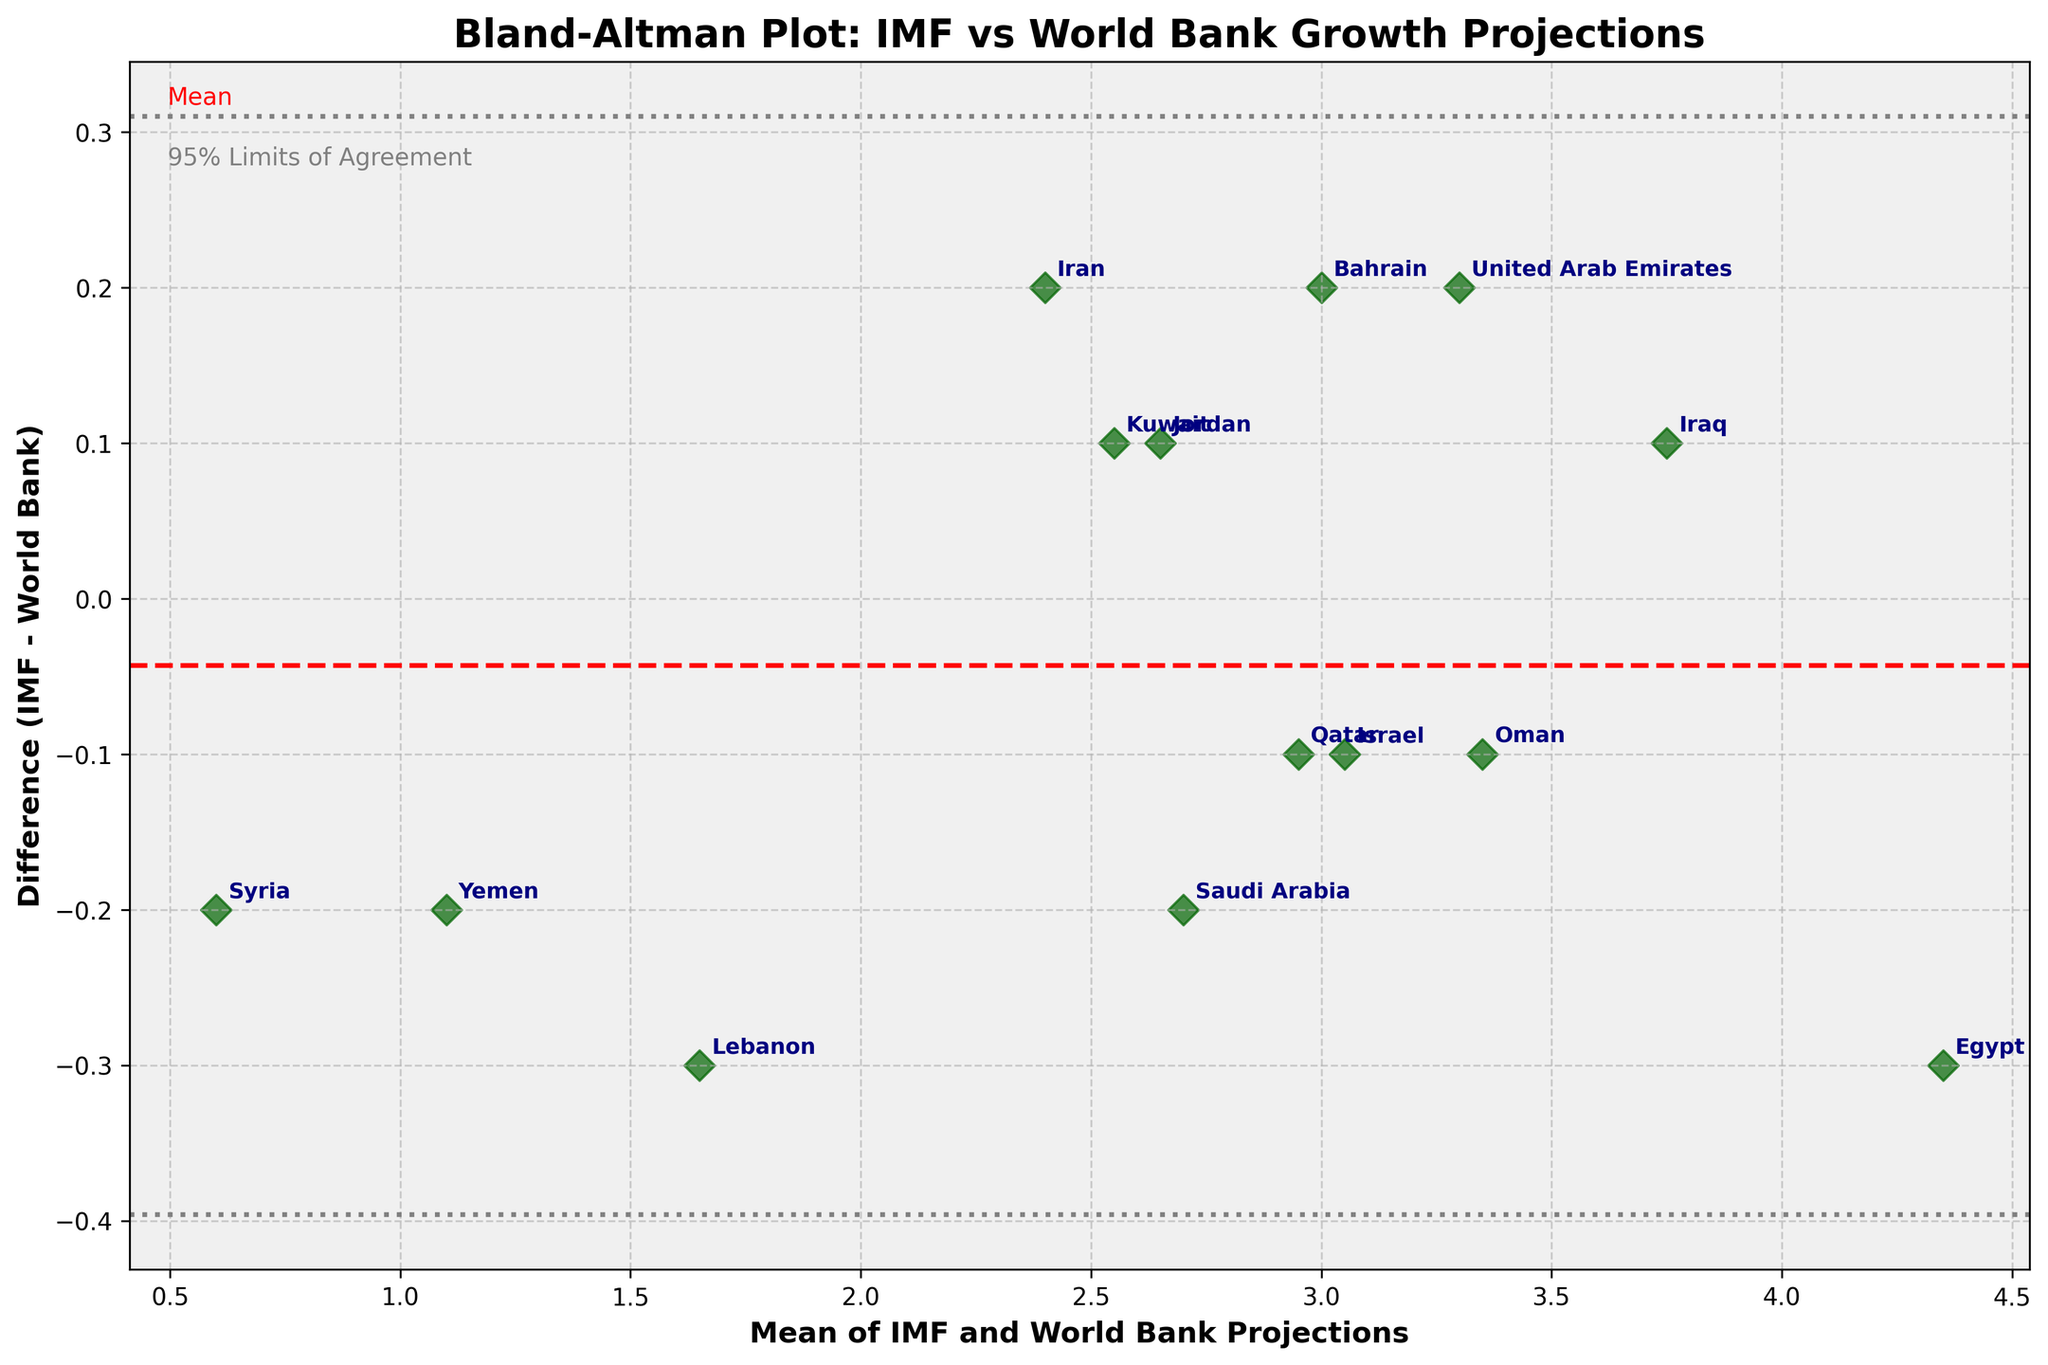How many countries are represented in the plot? By counting the countries listed in the dataset or their points on the plot, you will get the total number of represented countries. There are 14 countries listed.
Answer: 14 What's the title of the plot? The plot's title is positioned at the top of the figure and describes the main subject of the visualization. It reads, "Bland-Altman Plot: IMF vs World Bank Growth Projections".
Answer: Bland-Altman Plot: IMF vs World Bank Growth Projections What is the range of the mean of IMF and World Bank projections displayed on the x-axis? Observing the x-axis, the minimum and maximum values can be identified from the data points. The range is approximately from 0.6 to 4.35.
Answer: 0.6 to 4.35 Which country has the largest difference between IMF and World Bank projections? By examining the vertical distance of each point from the zero line on the y-axis, "Egypt" has the largest difference with a positive value of 0.3.
Answer: Egypt What does the red dashed horizontal line represent? The red dashed line typically represents the mean difference between the IMF and World Bank projections for all countries. This line helps identify any systematic bias.
Answer: Mean difference How many countries have higher IMF projections compared to World Bank projections? To find this, count the data points that are above the zero line on the y-axis, which represents positive differences (IMF is higher). There are 8 such points.
Answer: 8 Which country has the smallest absolute difference between the two projections and where is it located on the plot? By examining the closeness of points to the zero line on the y-axis, "Israel" has the smallest absolute difference, shown very close to zero.
Answer: Israel What do the gray dotted lines represent in the plot? These lines indicate the "95% Limits of Agreement," meaning most of the differences between IMF and World Bank projections should fall within these lines.
Answer: 95% Limits of Agreement What's the average IMF projection for the countries plotted? Adding all the IMF projections and dividing by the number of countries gives the average. (2.6 + 3.4 + 4.2 + 2.5 + 3.8 + 3.0 + 2.7 + 2.6 + 1.5 + 3.3 + 2.9 + 3.1 + 1.0 + 0.5) / 14 = 2.64
Answer: 2.64 How do outliers in a Bland-Altman plot inform us about the data? Outliers indicate countries where the projections significantly differ between IMF and World Bank, suggesting potential discrepancies or inconsistencies in the assessment of economic growth.
Answer: Identify discrepancies 